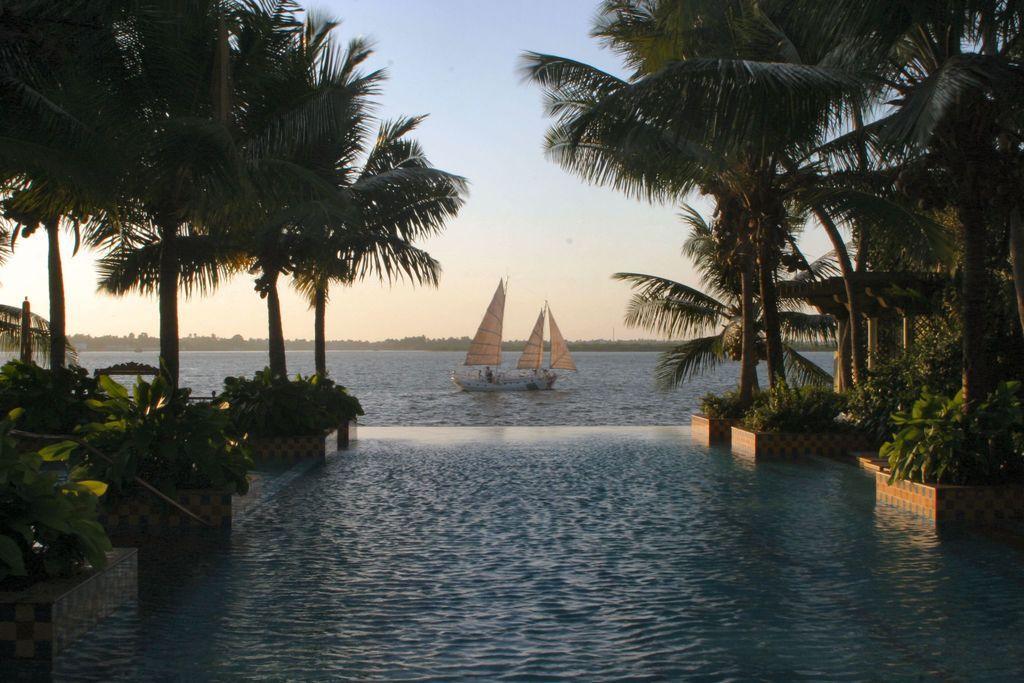Please provide a concise description of this image. In this image I see the plants, trees and I see the water and I see a boat over here. In the background I see the sky. 